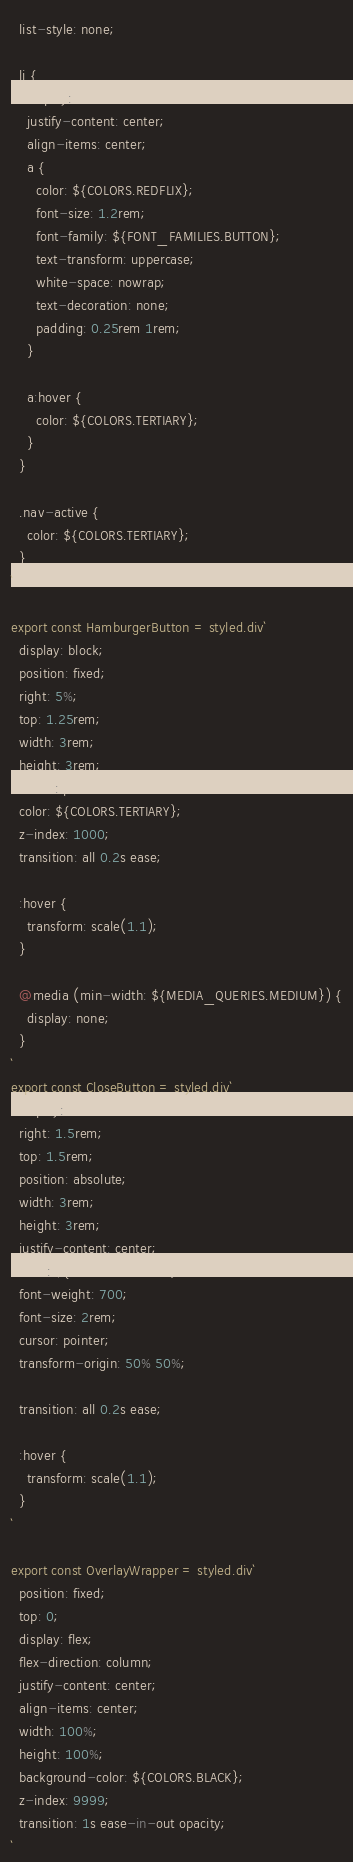Convert code to text. <code><loc_0><loc_0><loc_500><loc_500><_JavaScript_>  list-style: none;

  li {
    display: flex;
    justify-content: center;
    align-items: center;
    a {
      color: ${COLORS.REDFLIX};
      font-size: 1.2rem;
      font-family: ${FONT_FAMILIES.BUTTON};
      text-transform: uppercase;
      white-space: nowrap;
      text-decoration: none;
      padding: 0.25rem 1rem;
    }

    a:hover {
      color: ${COLORS.TERTIARY};
    }
  }

  .nav-active {
    color: ${COLORS.TERTIARY};
  }
`

export const HamburgerButton = styled.div`
  display: block;
  position: fixed;
  right: 5%;
  top: 1.25rem;
  width: 3rem;
  height: 3rem;
  cursor: pointer;
  color: ${COLORS.TERTIARY};
  z-index: 1000;
  transition: all 0.2s ease;

  :hover {
    transform: scale(1.1);
  }

  @media (min-width: ${MEDIA_QUERIES.MEDIUM}) {
    display: none;
  }
`
export const CloseButton = styled.div`
  display: flex;
  right: 1.5rem;
  top: 1.5rem;
  position: absolute;
  width: 3rem;
  height: 3rem;
  justify-content: center;
  color: ${COLORS.TERTIARY};
  font-weight: 700;
  font-size: 2rem;
  cursor: pointer;
  transform-origin: 50% 50%;

  transition: all 0.2s ease;

  :hover {
    transform: scale(1.1);
  }
`

export const OverlayWrapper = styled.div`
  position: fixed;
  top: 0;
  display: flex;
  flex-direction: column;
  justify-content: center;
  align-items: center;
  width: 100%;
  height: 100%;
  background-color: ${COLORS.BLACK};
  z-index: 9999;
  transition: 1s ease-in-out opacity;
`
</code> 